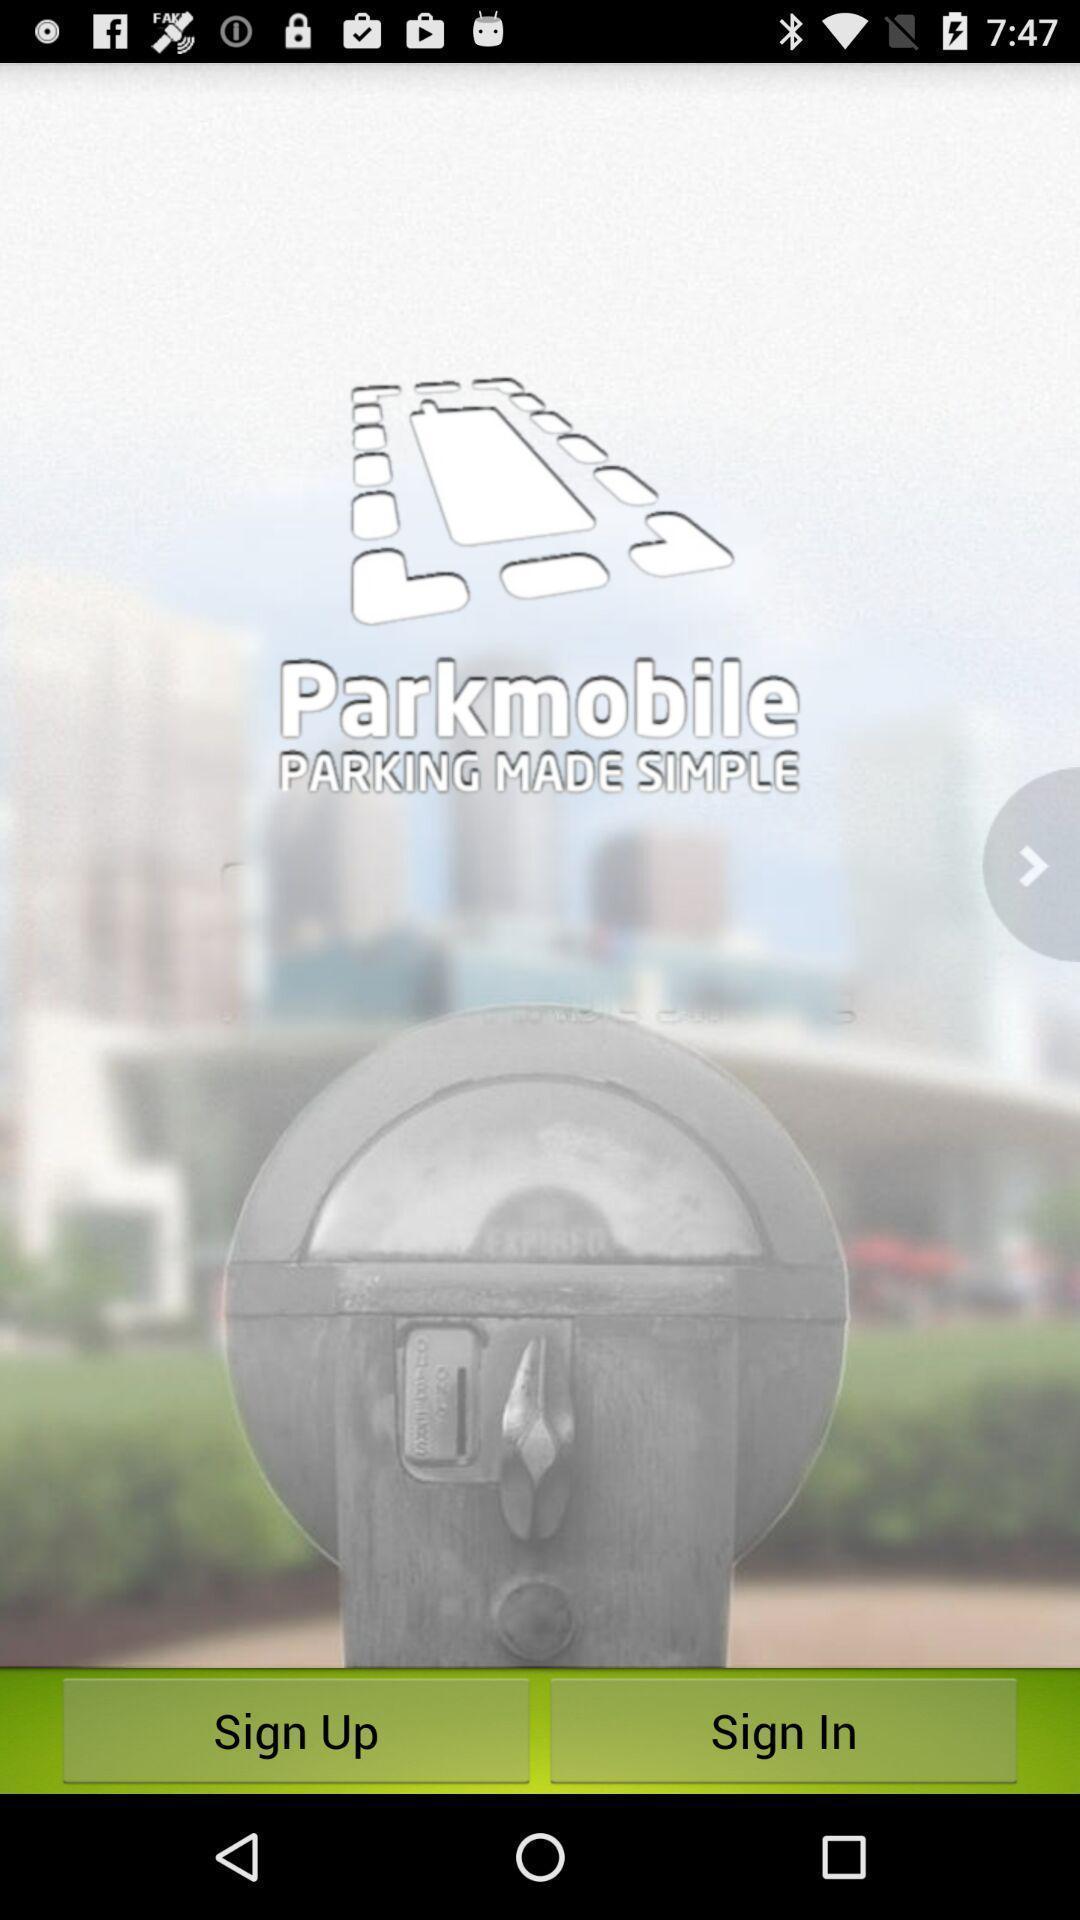Describe this image in words. Welcome page of a parking app. 